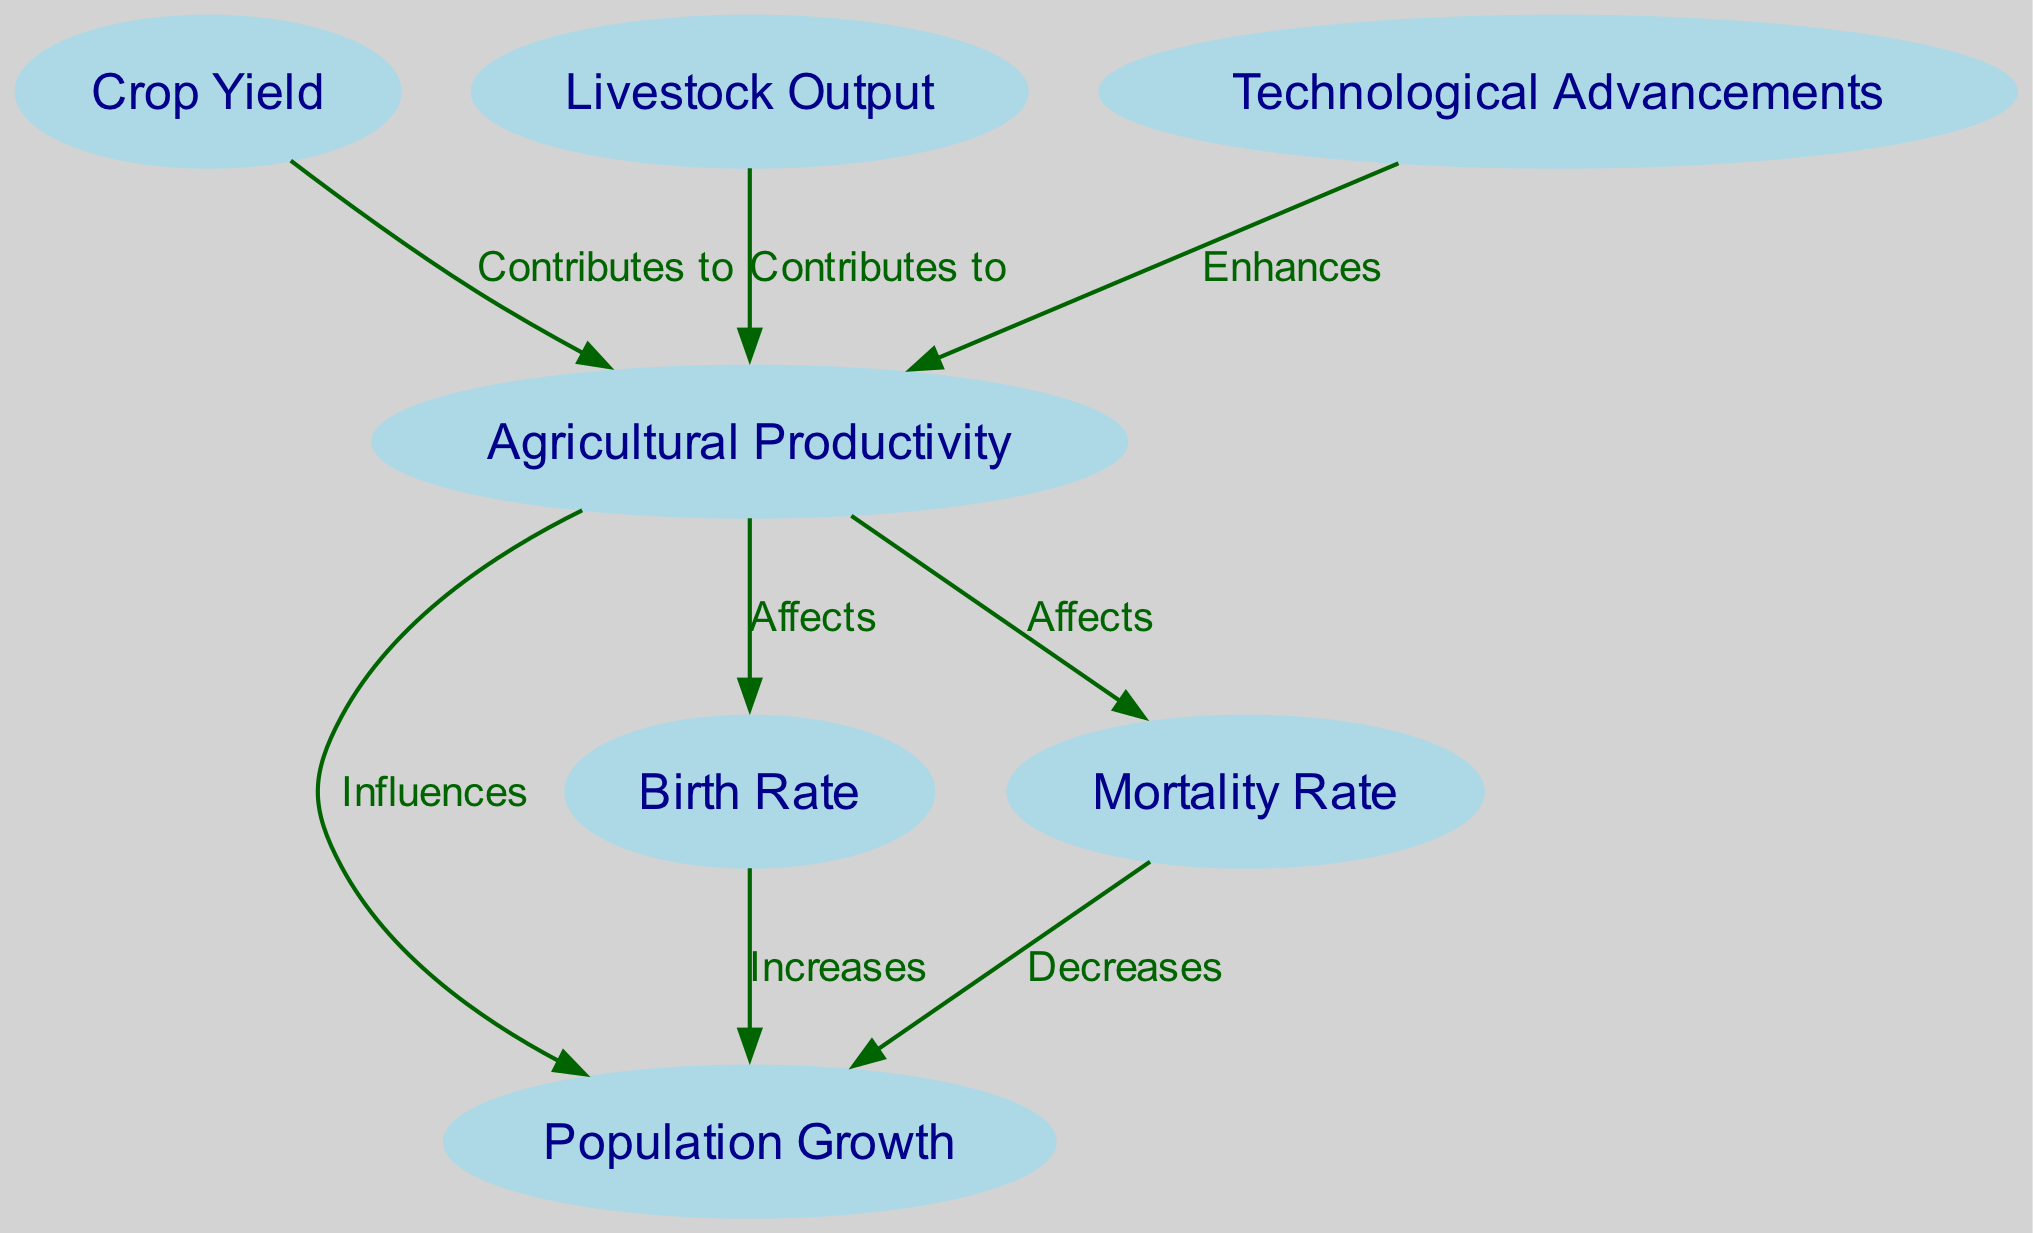What is the total number of nodes in the diagram? The diagram includes a set of nodes that represent different elements related to agricultural productivity and population growth. By counting each distinct node identified in the data, we find that there are seven nodes total.
Answer: Seven Which node directly influences population growth? The edge labeled "Influences" connects the node "Agricultural Productivity" to "Population Growth," indicating that agricultural productivity is the direct influence on population growth.
Answer: Agricultural Productivity How many edges are in the diagram? Each edge represents a relationship between the nodes. By counting the edges defined in the data, we find that there are eight edges in total.
Answer: Eight What does "Crop Yield" contribute to? The diagram shows an edge labeled "Contributes to" that connects "Crop Yield" to "Agricultural Productivity," indicating that crop yield is a contributing factor to agricultural productivity.
Answer: Agricultural Productivity What effect does "Mortality Rate" have on population growth? The diagram specifies that "Mortality Rate" decreases population growth as indicated by the edge labeled "Decreases" connecting it to "Population Growth."
Answer: Decreases Which node enhances agricultural productivity? The edge labeled "Enhances" in the diagram links "Technological Advancements" to "Agricultural Productivity," indicating that technological advancements enhance agricultural productivity.
Answer: Technological Advancements What are the two factors affecting mortality rate? The diagram shows two edges connecting to the "Mortality Rate": one from "Agricultural Productivity" labeled "Affects" and another from "Population Growth" also labeled "Affects." This indicates that both of these factors affect the mortality rate.
Answer: Agricultural Productivity and Population Growth What is the connection between birth rate and population growth? The edge labeled "Increases" connects "Birth Rate" to "Population Growth," meaning that an increase in the birth rate leads to an increase in population growth.
Answer: Increases 